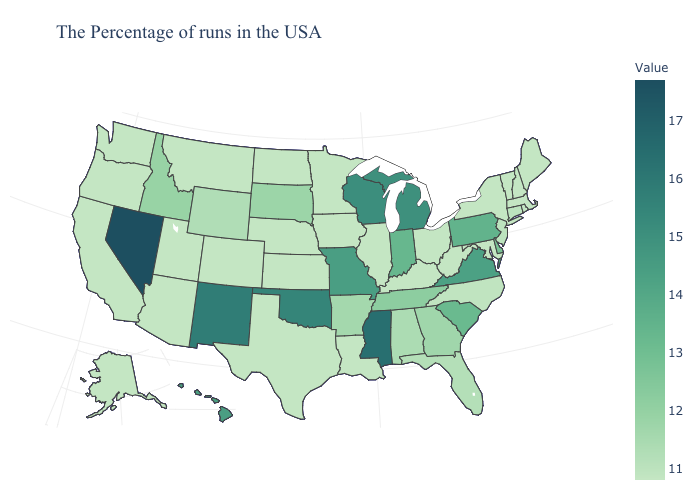Is the legend a continuous bar?
Be succinct. Yes. Does California have the lowest value in the USA?
Quick response, please. Yes. Among the states that border Iowa , does Wisconsin have the highest value?
Short answer required. Yes. Which states have the lowest value in the USA?
Be succinct. Maine, Massachusetts, Rhode Island, New Hampshire, Vermont, New York, Maryland, West Virginia, Ohio, Kentucky, Illinois, Louisiana, Minnesota, Iowa, Kansas, Nebraska, Texas, North Dakota, Colorado, Utah, Montana, Arizona, California, Washington, Oregon, Alaska. Which states have the lowest value in the MidWest?
Quick response, please. Ohio, Illinois, Minnesota, Iowa, Kansas, Nebraska, North Dakota. Does Nevada have the highest value in the USA?
Short answer required. Yes. Which states have the lowest value in the USA?
Quick response, please. Maine, Massachusetts, Rhode Island, New Hampshire, Vermont, New York, Maryland, West Virginia, Ohio, Kentucky, Illinois, Louisiana, Minnesota, Iowa, Kansas, Nebraska, Texas, North Dakota, Colorado, Utah, Montana, Arizona, California, Washington, Oregon, Alaska. 